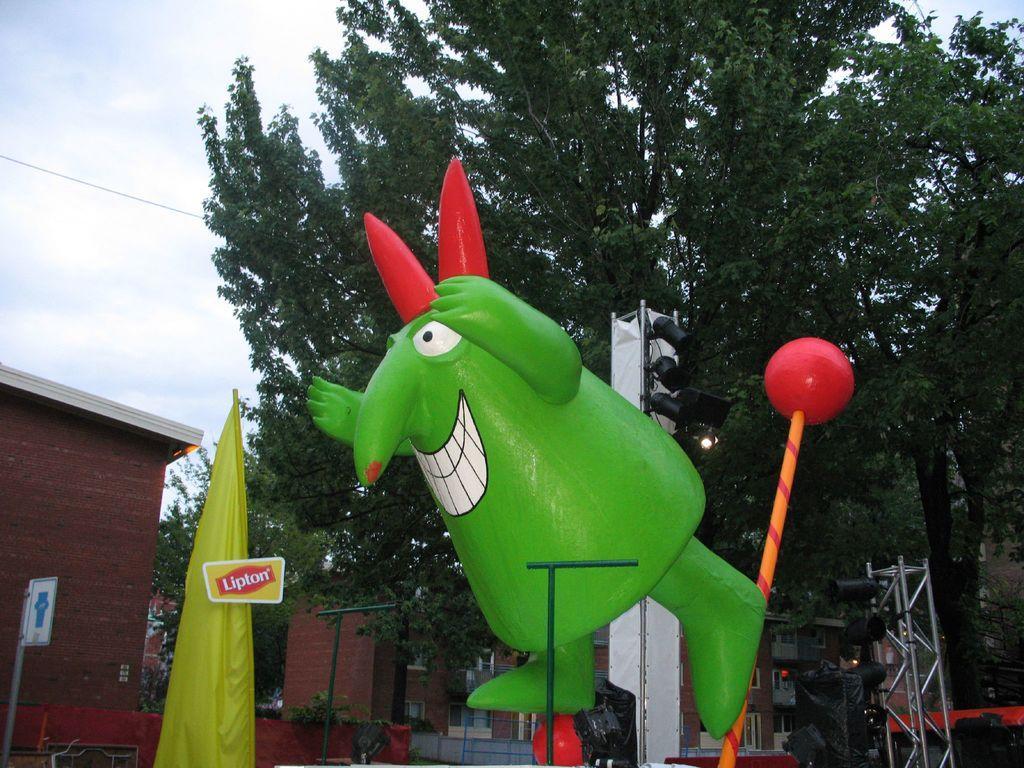How would you summarize this image in a sentence or two? In the image there is a statue of a cartoon in the front with a stage equipment behind it and in the back there are buildings and trees and above its sky with clouds. 